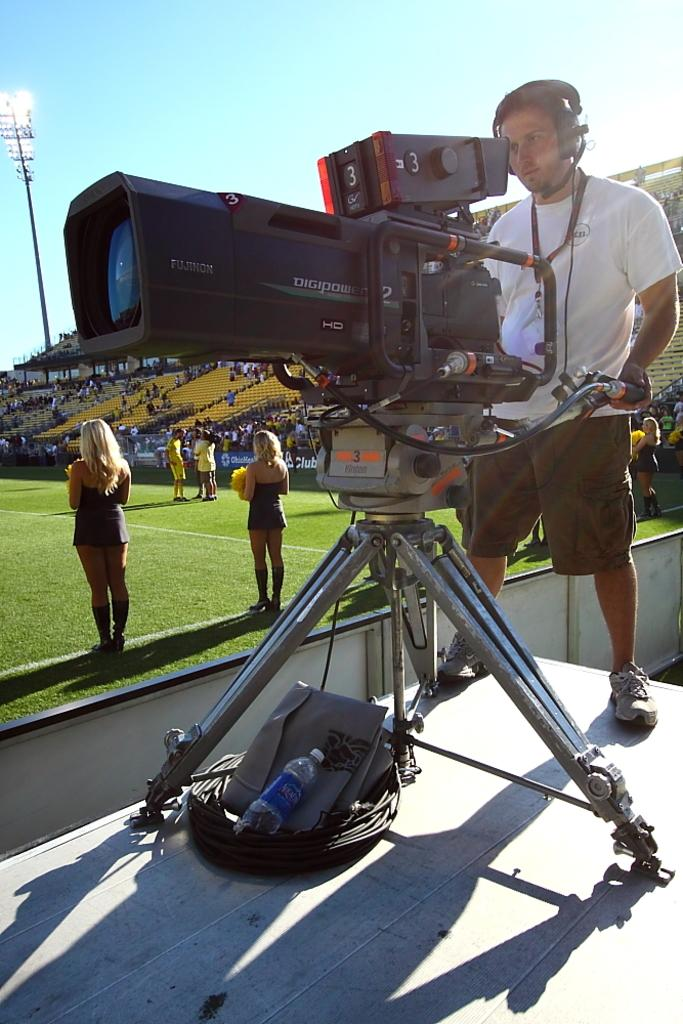<image>
Write a terse but informative summary of the picture. Camera man operating a camera that says the word "Digipower" on the side. 